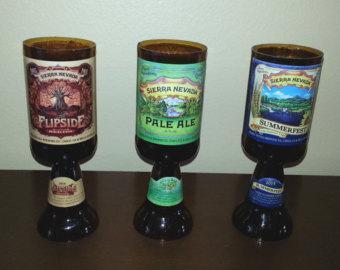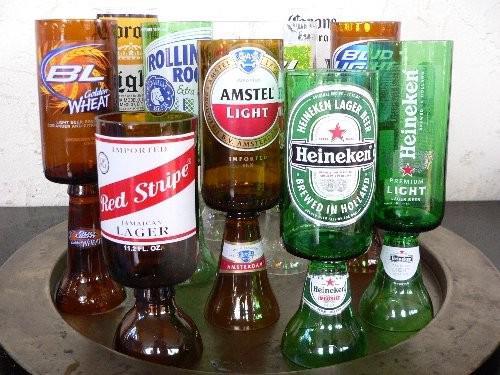The first image is the image on the left, the second image is the image on the right. Examine the images to the left and right. Is the description "There are less than four bottles in one of the pictures." accurate? Answer yes or no. Yes. 